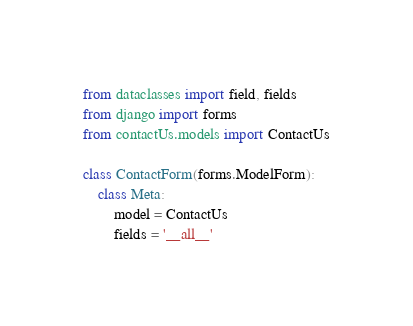<code> <loc_0><loc_0><loc_500><loc_500><_Python_>from dataclasses import field, fields
from django import forms
from contactUs.models import ContactUs

class ContactForm(forms.ModelForm):
    class Meta:
        model = ContactUs
        fields = '__all__'</code> 